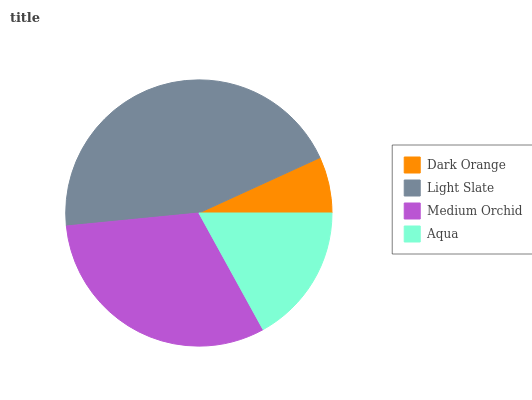Is Dark Orange the minimum?
Answer yes or no. Yes. Is Light Slate the maximum?
Answer yes or no. Yes. Is Medium Orchid the minimum?
Answer yes or no. No. Is Medium Orchid the maximum?
Answer yes or no. No. Is Light Slate greater than Medium Orchid?
Answer yes or no. Yes. Is Medium Orchid less than Light Slate?
Answer yes or no. Yes. Is Medium Orchid greater than Light Slate?
Answer yes or no. No. Is Light Slate less than Medium Orchid?
Answer yes or no. No. Is Medium Orchid the high median?
Answer yes or no. Yes. Is Aqua the low median?
Answer yes or no. Yes. Is Light Slate the high median?
Answer yes or no. No. Is Dark Orange the low median?
Answer yes or no. No. 